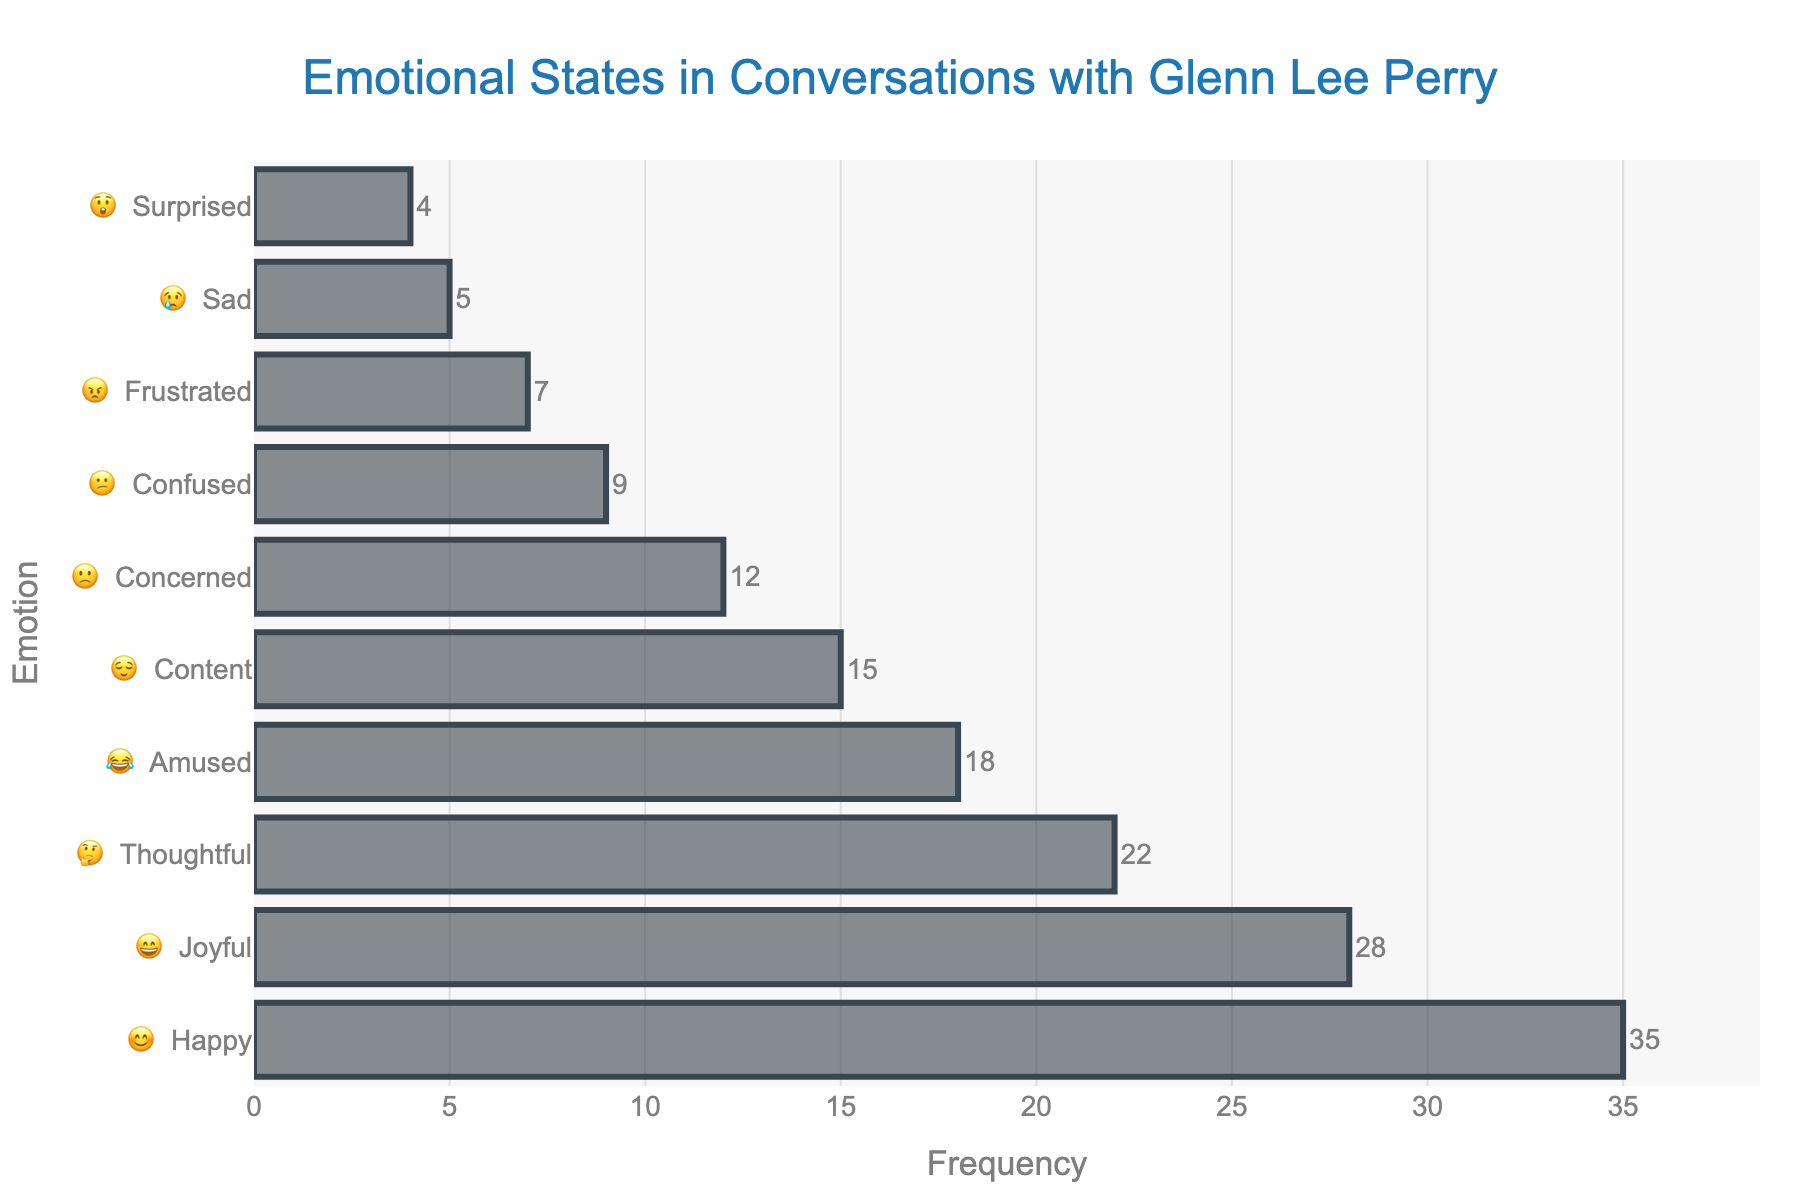what is the most frequent emotional state? The most frequent emotional state can be identified as the one with the highest bar. According to the chart, "😊 Happy" has the highest frequency.
Answer: 😊 Happy How many emotional states have a frequency higher than 20? Count the number of emotional states that have frequencies greater than 20. They are 😊 Happy (35), 😄 Joyful (28), and 🤔 Thoughtful (22).
Answer: 3 What is the total frequency of all emotions? Sum all the frequencies: 35 (😊 Happy) + 28 (😄 Joyful) + 22 (🤔 Thoughtful) + 18 (😂 Amused) + 15 (😌 Content) + 12 (🙁 Concerned) + 9 (😕 Confused) + 7 (😠 Frustrated) + 5 (😢 Sad) + 4 (😲 Surprised).
Answer: 155 Which emotion is more frequent: 😉 Joyful or 🤔 Thoughtful? Compare the frequencies of 😄 Joyful (28) and 🤔 Thoughtful (22). 😄 Joyful has a higher frequency.
Answer: 😄 Joyful What's the sum of the frequencies of the least frequent three emotions? Identify the three least frequent emotions: 😲 Surprised (4), 😢 Sad (5), and 😠 Frustrated (7). Sum their frequencies: 4 + 5 + 7.
Answer: 16 Which emotion has a frequency less than 10 but more than 5? Identify the emotions with frequencies between 6 and 9. This includes 🙁 Concerned (12), 😕 Confused (9), and 😠 Frustrated (7). Only 😠 Frustrated fits the criteria.
Answer: 😠 Frustrated What's the difference between the most frequent and least frequent emotions? The most frequent emotion is 😊 Happy (35), and the least frequent is 😲 Surprised (4). Subtract the frequency of the least frequent from the most frequent: 35 - 4.
Answer: 31 How does the frequency of 😂 Amused compare to 😌 Content? Compare the frequencies: 😂 Amused has 18, and 😌 Content has 15. 😂 Amused is more frequent.
Answer: 😂 Amused 